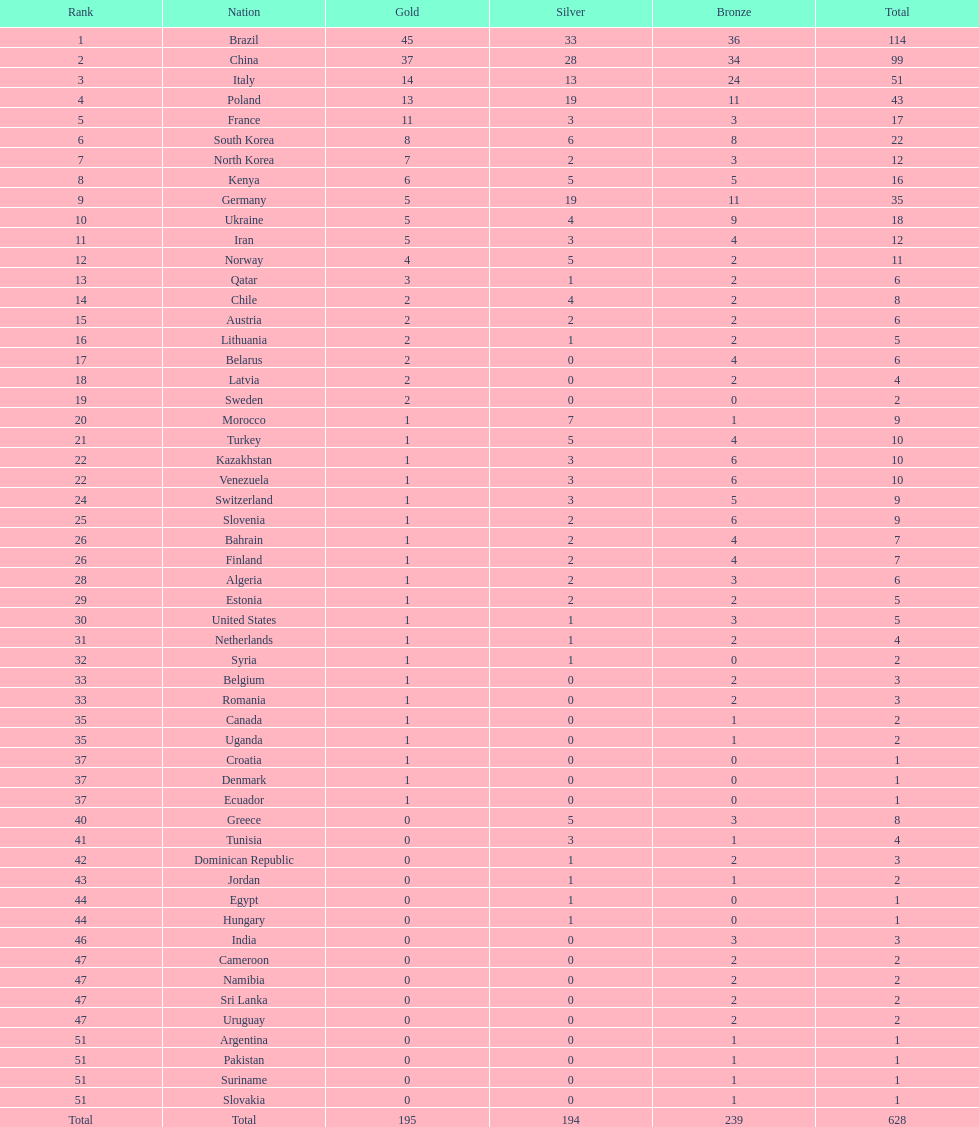Which country garnered the most gold medals? Brazil. 